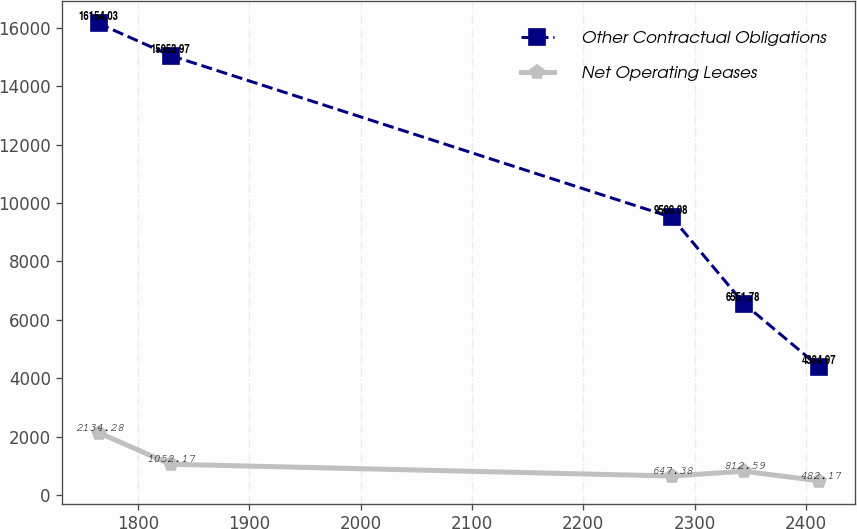<chart> <loc_0><loc_0><loc_500><loc_500><line_chart><ecel><fcel>Other Contractual Obligations<fcel>Net Operating Leases<nl><fcel>1764.56<fcel>16154<fcel>2134.28<nl><fcel>1829.32<fcel>15054<fcel>1052.17<nl><fcel>2279.61<fcel>9509.08<fcel>647.38<nl><fcel>2344.37<fcel>6551.78<fcel>812.59<nl><fcel>2412.16<fcel>4384.97<fcel>482.17<nl></chart> 